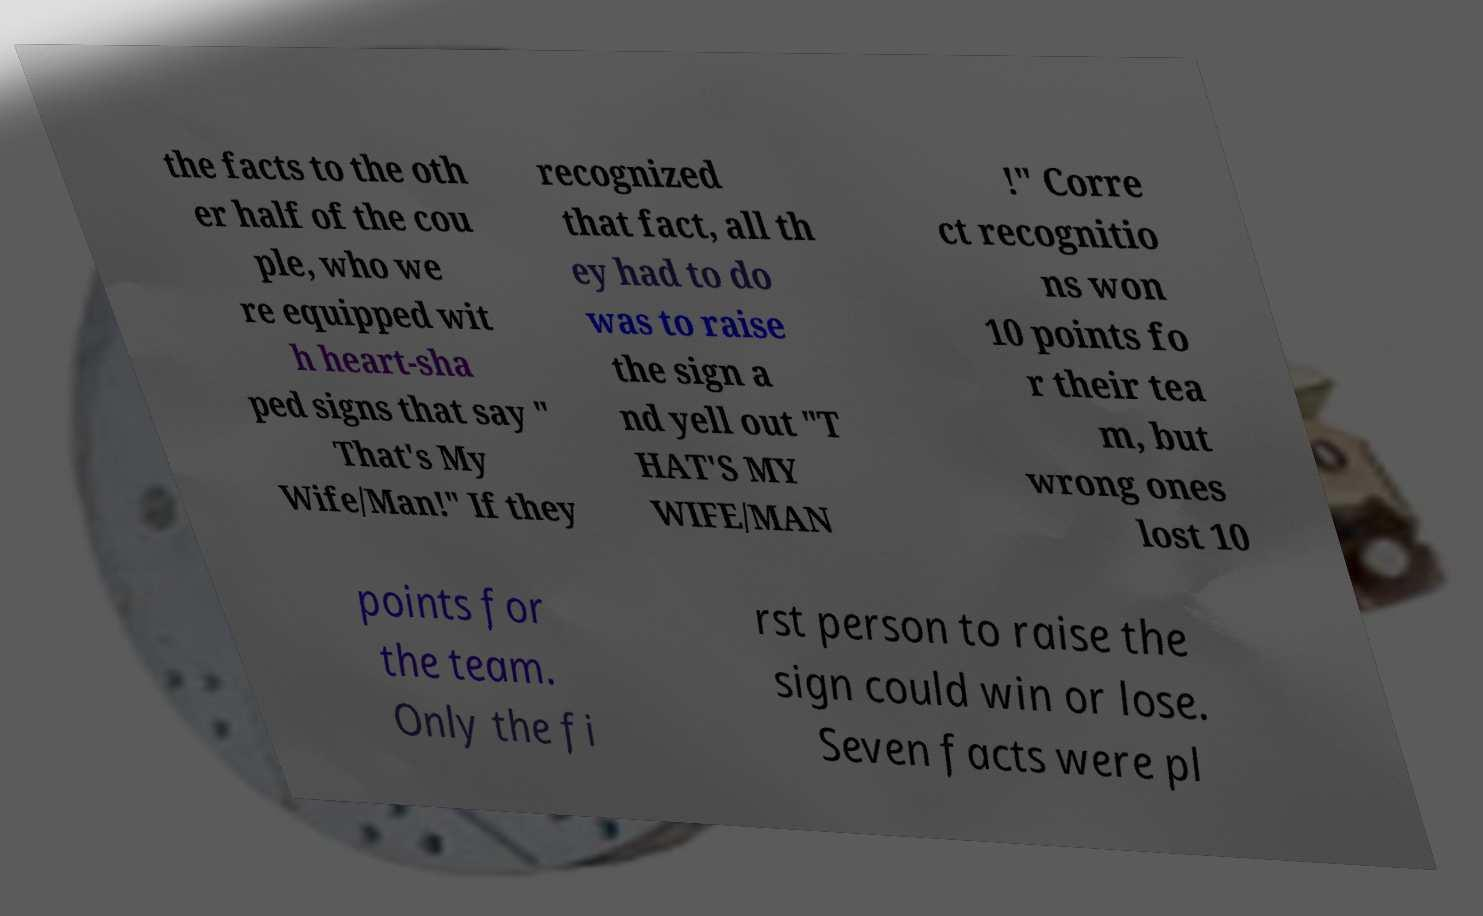Can you read and provide the text displayed in the image?This photo seems to have some interesting text. Can you extract and type it out for me? the facts to the oth er half of the cou ple, who we re equipped wit h heart-sha ped signs that say " That's My Wife/Man!" If they recognized that fact, all th ey had to do was to raise the sign a nd yell out "T HAT'S MY WIFE/MAN !" Corre ct recognitio ns won 10 points fo r their tea m, but wrong ones lost 10 points for the team. Only the fi rst person to raise the sign could win or lose. Seven facts were pl 